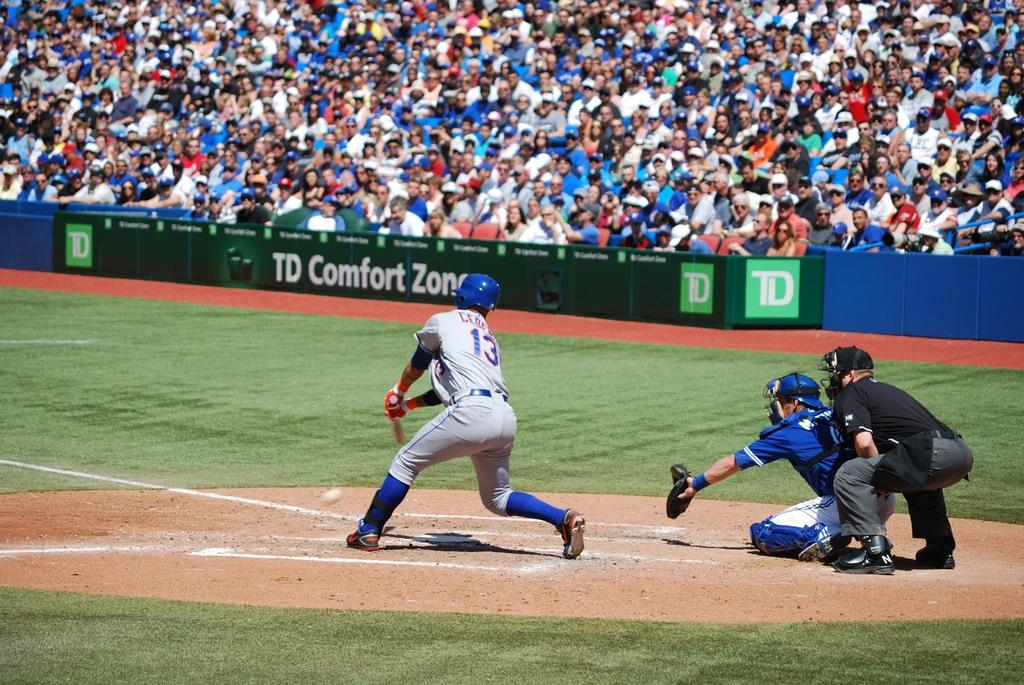<image>
Write a terse but informative summary of the picture. A baseball player is trying to hit a ball on a field that has a banner for TC Comfort Zone on the wall. 